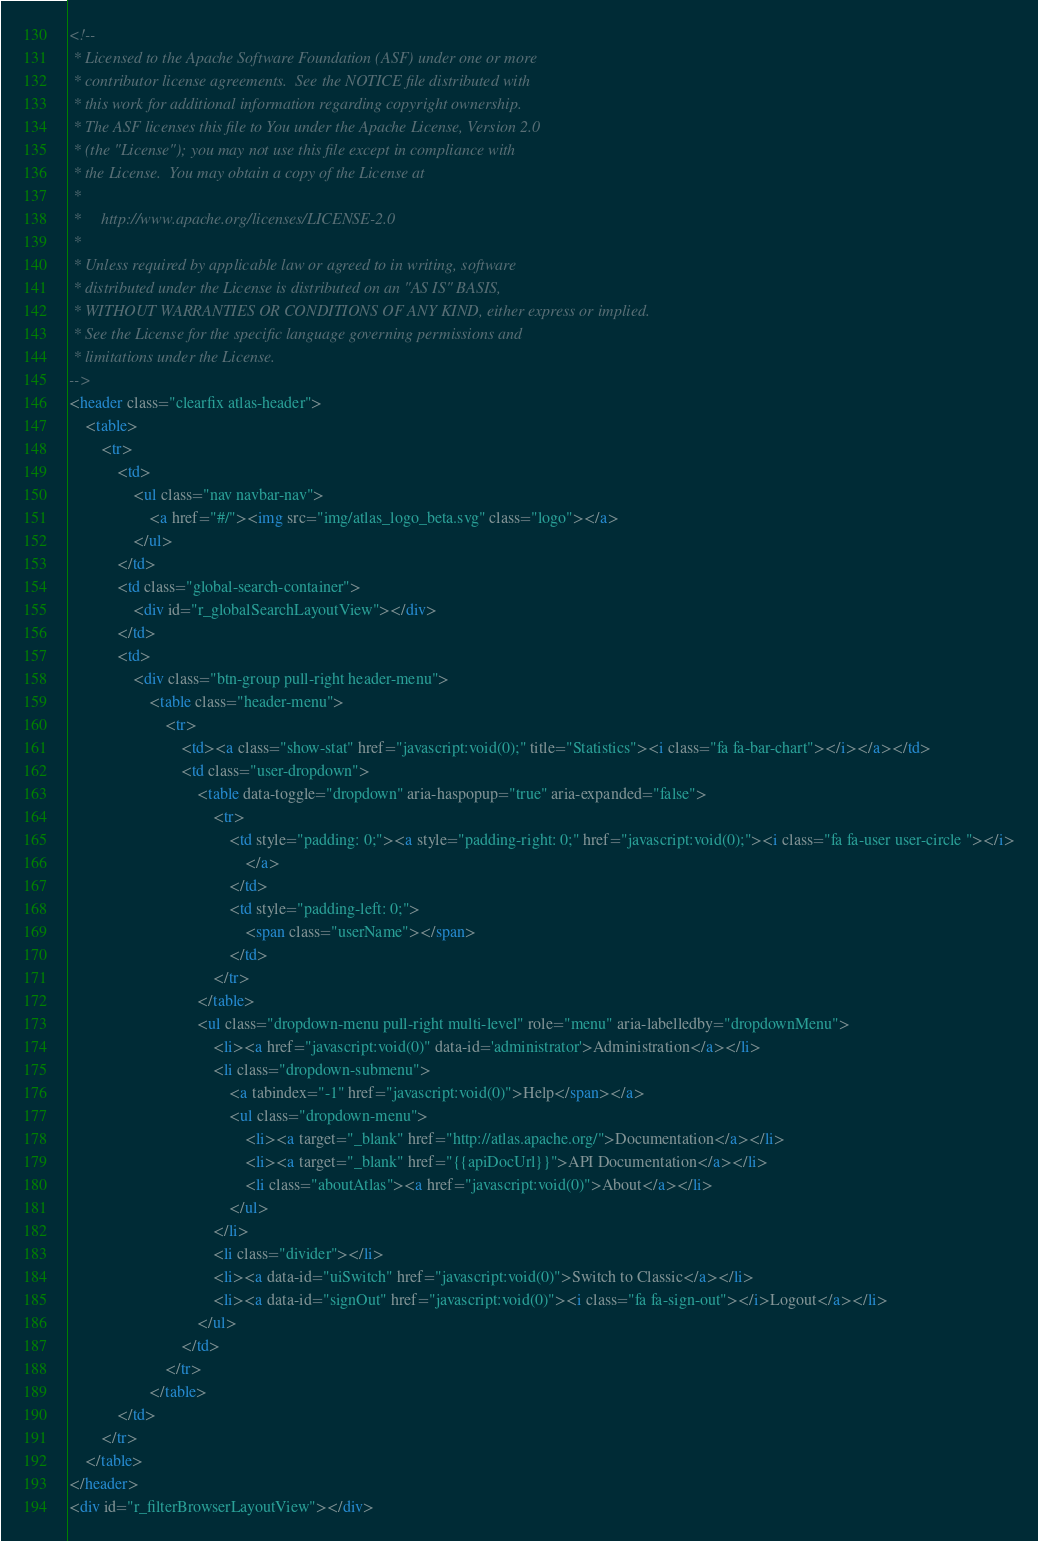<code> <loc_0><loc_0><loc_500><loc_500><_HTML_><!--
 * Licensed to the Apache Software Foundation (ASF) under one or more
 * contributor license agreements.  See the NOTICE file distributed with
 * this work for additional information regarding copyright ownership.
 * The ASF licenses this file to You under the Apache License, Version 2.0
 * (the "License"); you may not use this file except in compliance with
 * the License.  You may obtain a copy of the License at
 *
 *     http://www.apache.org/licenses/LICENSE-2.0
 *
 * Unless required by applicable law or agreed to in writing, software
 * distributed under the License is distributed on an "AS IS" BASIS,
 * WITHOUT WARRANTIES OR CONDITIONS OF ANY KIND, either express or implied.
 * See the License for the specific language governing permissions and
 * limitations under the License.
-->
<header class="clearfix atlas-header">
    <table>
        <tr>
            <td>
                <ul class="nav navbar-nav">
                    <a href="#/"><img src="img/atlas_logo_beta.svg" class="logo"></a>
                </ul>
            </td>
            <td class="global-search-container">
                <div id="r_globalSearchLayoutView"></div>
            </td>
            <td>
                <div class="btn-group pull-right header-menu">
                    <table class="header-menu">
                        <tr>
                            <td><a class="show-stat" href="javascript:void(0);" title="Statistics"><i class="fa fa-bar-chart"></i></a></td>
                            <td class="user-dropdown">
                                <table data-toggle="dropdown" aria-haspopup="true" aria-expanded="false">
                                    <tr>
                                        <td style="padding: 0;"><a style="padding-right: 0;" href="javascript:void(0);"><i class="fa fa-user user-circle "></i>
                                            </a>
                                        </td>
                                        <td style="padding-left: 0;">
                                            <span class="userName"></span>
                                        </td>
                                    </tr>
                                </table>
                                <ul class="dropdown-menu pull-right multi-level" role="menu" aria-labelledby="dropdownMenu">
                                    <li><a href="javascript:void(0)" data-id='administrator'>Administration</a></li>
                                    <li class="dropdown-submenu">
                                        <a tabindex="-1" href="javascript:void(0)">Help</span></a>
                                        <ul class="dropdown-menu">
                                            <li><a target="_blank" href="http://atlas.apache.org/">Documentation</a></li>
                                            <li><a target="_blank" href="{{apiDocUrl}}">API Documentation</a></li>
                                            <li class="aboutAtlas"><a href="javascript:void(0)">About</a></li>
                                        </ul>
                                    </li>
                                    <li class="divider"></li>
                                    <li><a data-id="uiSwitch" href="javascript:void(0)">Switch to Classic</a></li>
                                    <li><a data-id="signOut" href="javascript:void(0)"><i class="fa fa-sign-out"></i>Logout</a></li>
                                </ul>
                            </td>
                        </tr>
                    </table>
            </td>
        </tr>
    </table>
</header>
<div id="r_filterBrowserLayoutView"></div></code> 